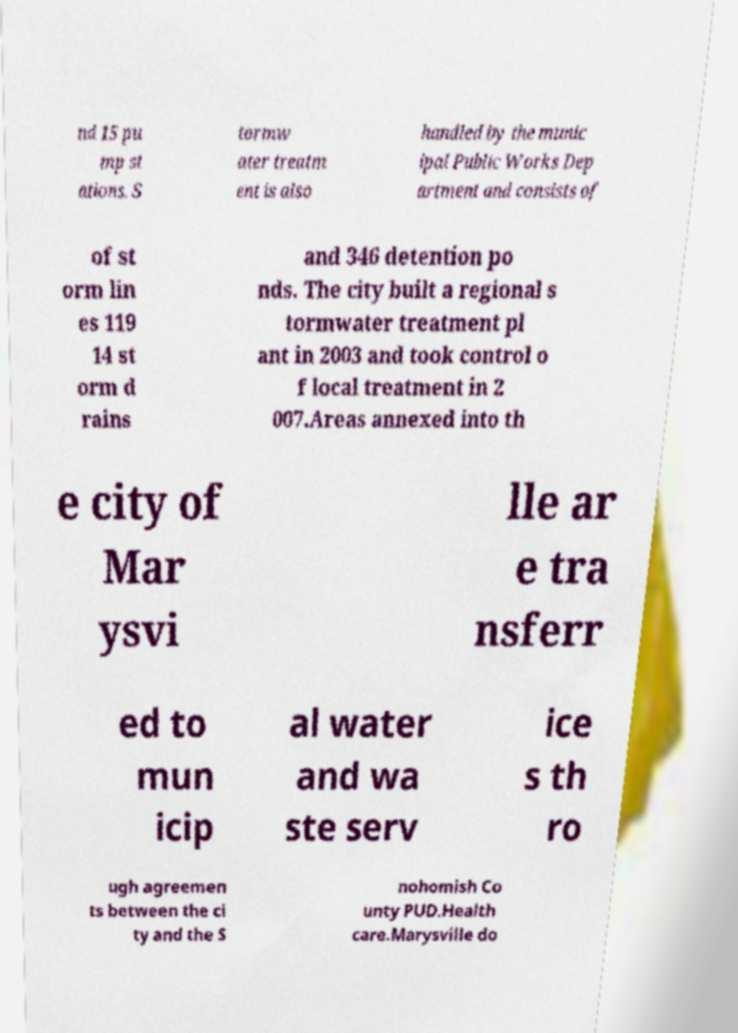There's text embedded in this image that I need extracted. Can you transcribe it verbatim? nd 15 pu mp st ations. S tormw ater treatm ent is also handled by the munic ipal Public Works Dep artment and consists of of st orm lin es 119 14 st orm d rains and 346 detention po nds. The city built a regional s tormwater treatment pl ant in 2003 and took control o f local treatment in 2 007.Areas annexed into th e city of Mar ysvi lle ar e tra nsferr ed to mun icip al water and wa ste serv ice s th ro ugh agreemen ts between the ci ty and the S nohomish Co unty PUD.Health care.Marysville do 